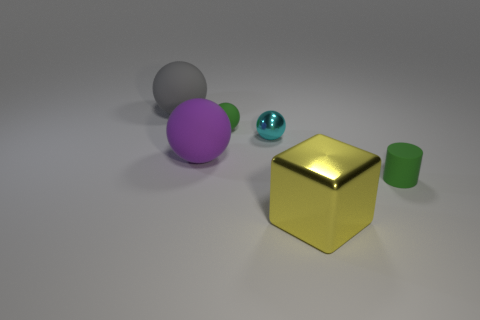Are there any other things that are the same size as the yellow metal cube?
Give a very brief answer. Yes. How many brown balls have the same size as the yellow metal block?
Make the answer very short. 0. Are there the same number of metal cubes right of the block and cubes?
Your answer should be compact. No. What number of objects are both in front of the gray ball and to the left of the tiny green rubber cylinder?
Offer a terse response. 4. There is a big matte thing that is in front of the large gray thing; does it have the same shape as the big gray object?
Ensure brevity in your answer.  Yes. What material is the gray sphere that is the same size as the block?
Your answer should be very brief. Rubber. Are there the same number of small cylinders behind the large gray matte thing and large gray spheres that are in front of the green ball?
Your answer should be very brief. Yes. There is a metallic object that is in front of the tiny green rubber object in front of the cyan sphere; what number of big purple things are in front of it?
Your answer should be compact. 0. There is a tiny rubber cylinder; does it have the same color as the tiny rubber thing that is behind the small cyan thing?
Provide a short and direct response. Yes. The gray thing that is the same material as the purple sphere is what size?
Keep it short and to the point. Large. 